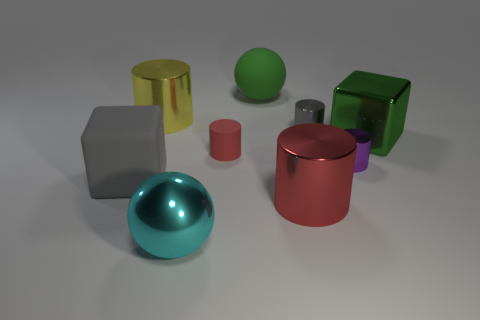What is the color of the big cylinder that is in front of the big rubber thing in front of the small thing right of the tiny gray metallic object?
Provide a succinct answer. Red. There is a cyan sphere; does it have the same size as the red cylinder right of the matte ball?
Your answer should be compact. Yes. What number of objects are either matte objects that are in front of the purple metal cylinder or large shiny things behind the large gray block?
Ensure brevity in your answer.  3. The red thing that is the same size as the purple thing is what shape?
Ensure brevity in your answer.  Cylinder. What is the shape of the large matte thing that is to the right of the small cylinder on the left side of the sphere behind the purple cylinder?
Offer a very short reply. Sphere. Are there the same number of yellow metallic cylinders left of the small gray metallic object and yellow metallic things?
Give a very brief answer. Yes. Is the green matte ball the same size as the shiny sphere?
Provide a short and direct response. Yes. What number of rubber things are objects or purple cubes?
Offer a terse response. 3. What material is the gray block that is the same size as the yellow thing?
Make the answer very short. Rubber. What number of other objects are the same material as the cyan sphere?
Offer a terse response. 5. 